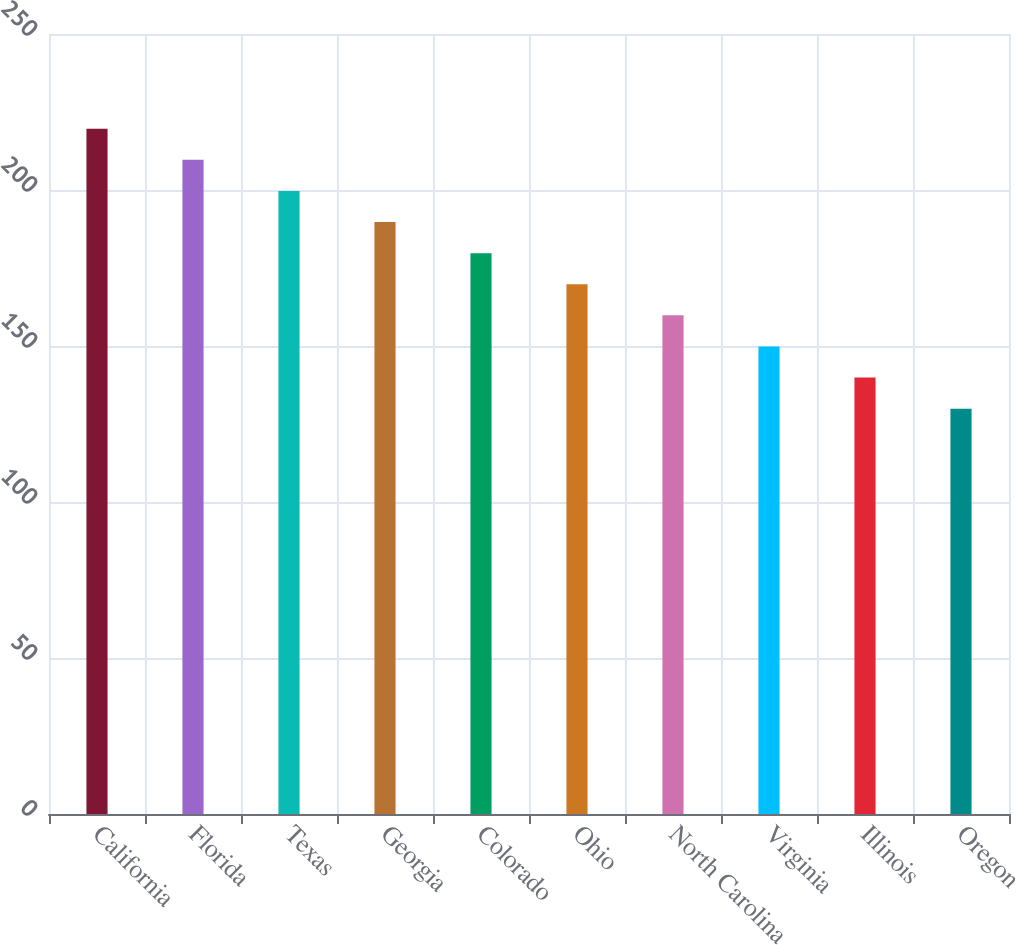<chart> <loc_0><loc_0><loc_500><loc_500><bar_chart><fcel>California<fcel>Florida<fcel>Texas<fcel>Georgia<fcel>Colorado<fcel>Ohio<fcel>North Carolina<fcel>Virginia<fcel>Illinois<fcel>Oregon<nl><fcel>219.64<fcel>209.67<fcel>199.7<fcel>189.73<fcel>179.76<fcel>169.79<fcel>159.82<fcel>149.85<fcel>139.88<fcel>129.91<nl></chart> 